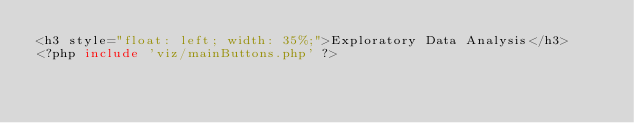Convert code to text. <code><loc_0><loc_0><loc_500><loc_500><_PHP_><h3 style="float: left; width: 35%;">Exploratory Data Analysis</h3>
<?php include 'viz/mainButtons.php' ?></code> 